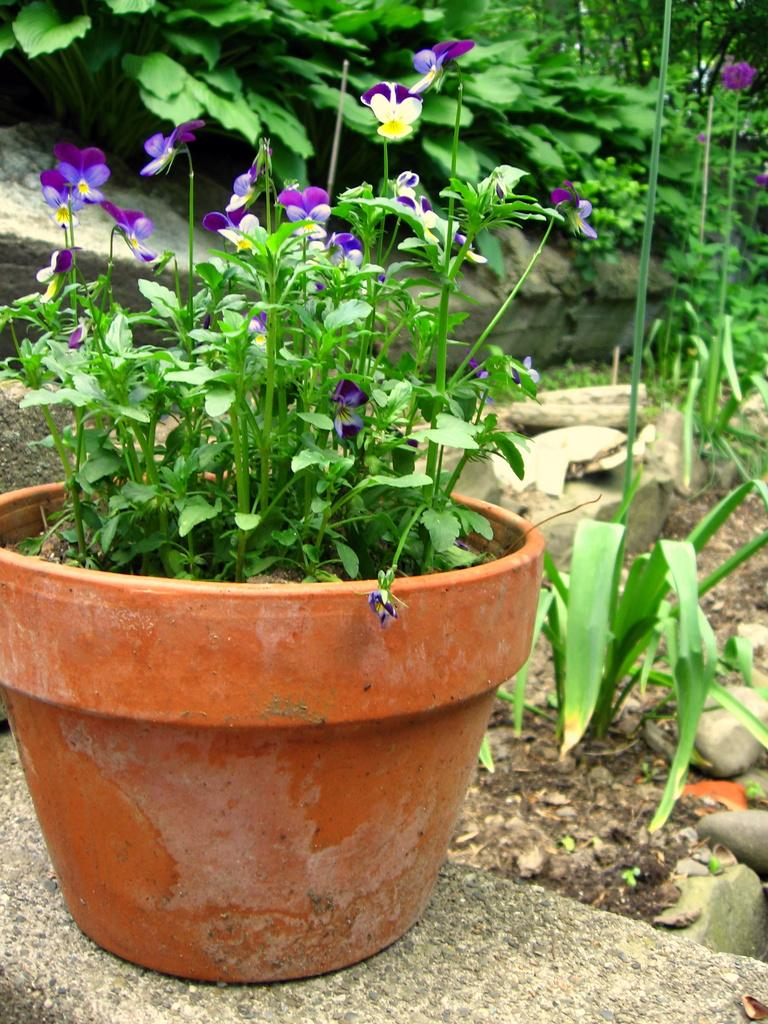What is located on the platform in the image? There is a house plant on a platform in the image. What is special about the house plant? The house plant has flowers. What can be seen in the background of the image? There are plants and stones on the ground in the background of the image. How much liquid is contained in the house plant in the image? There is no liquid present in the house plant in the image; it is a plant with flowers. What type of bean is visible in the image? There are no beans present in the image. 